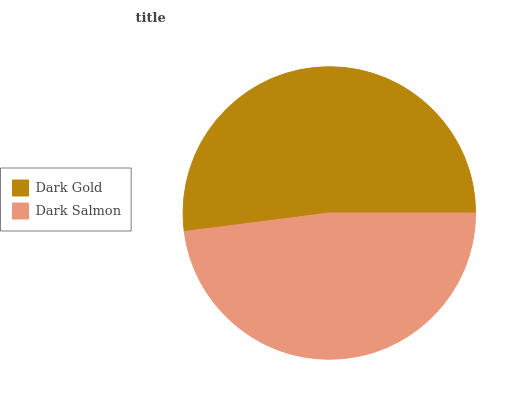Is Dark Salmon the minimum?
Answer yes or no. Yes. Is Dark Gold the maximum?
Answer yes or no. Yes. Is Dark Salmon the maximum?
Answer yes or no. No. Is Dark Gold greater than Dark Salmon?
Answer yes or no. Yes. Is Dark Salmon less than Dark Gold?
Answer yes or no. Yes. Is Dark Salmon greater than Dark Gold?
Answer yes or no. No. Is Dark Gold less than Dark Salmon?
Answer yes or no. No. Is Dark Gold the high median?
Answer yes or no. Yes. Is Dark Salmon the low median?
Answer yes or no. Yes. Is Dark Salmon the high median?
Answer yes or no. No. Is Dark Gold the low median?
Answer yes or no. No. 